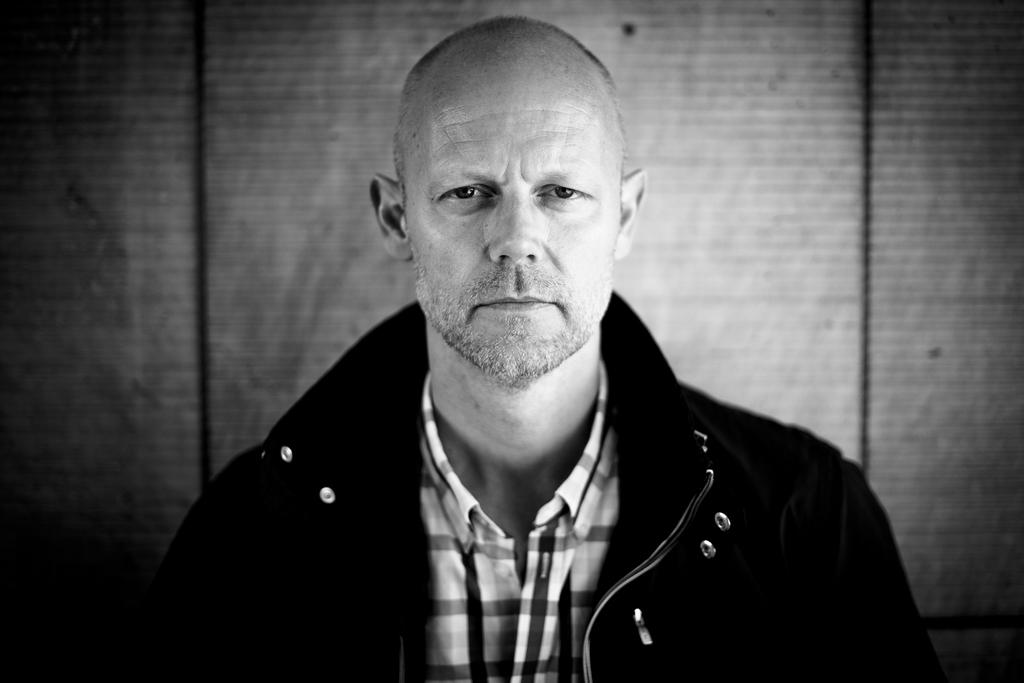What is the color scheme of the image? The image is black and white. Who is present in the image? There is a man in the image. What is the man wearing? The man is wearing a jacket. What is the man doing in the image? The man is looking at a picture. What can be seen in the background of the image? There is a wall in the background of the image. Can you see a rabbit holding a gun in the image? No, there is no rabbit or gun present in the image. What type of sign is the man holding in the image? There is no sign present in the image; the man is looking at a picture. 